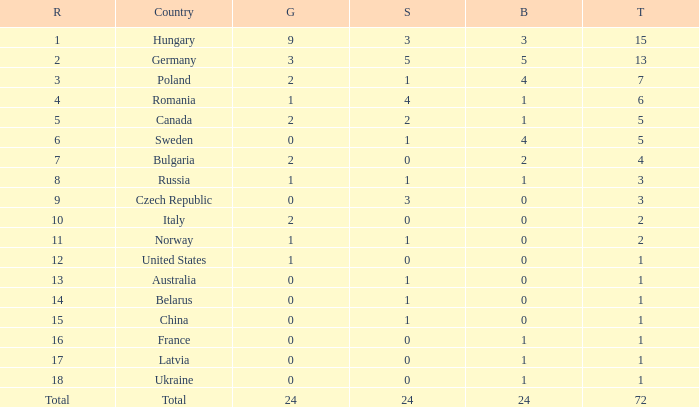What average silver has belarus as the nation, with a total less than 1? None. 